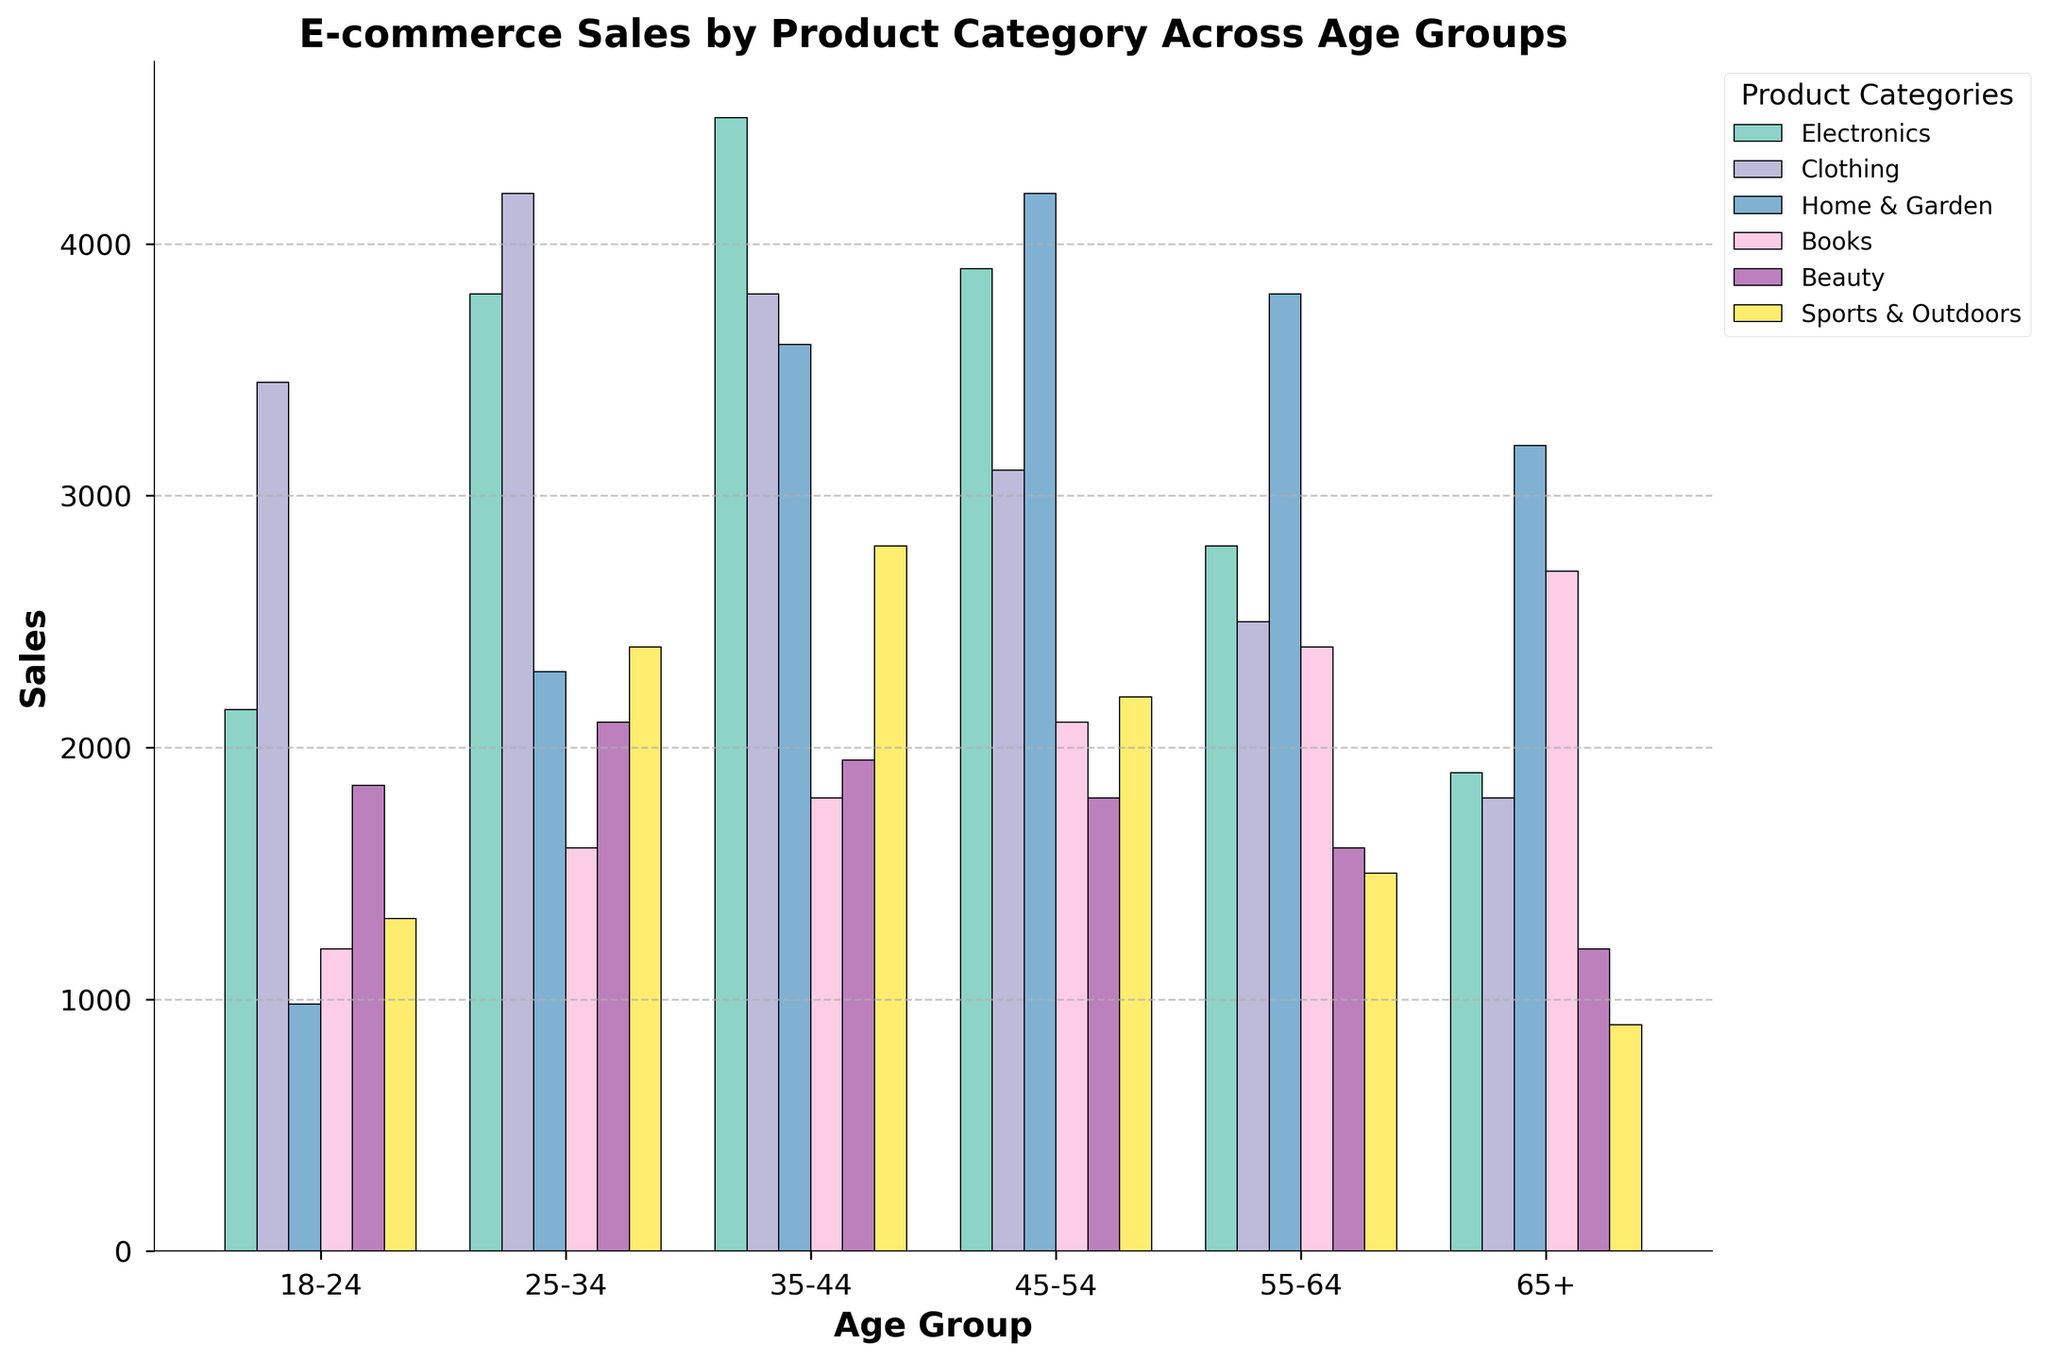What's the most popular product category for the age group 35-44? The bar representing each product category for the 35-44 age group shows that Electronics has the highest bar, indicating it has the highest number of sales.
Answer: Electronics How do sales for Home & Garden in the 45-54 age group compare to the 55-64 age group? By comparing the heights of the Home & Garden bars for the two age groups, we observe that the 55-64 age group has a slightly higher bar indicating more sales compared to the 45-54 age group.
Answer: 55-64 age group has higher sales Which age group has the highest total sales across all product categories? To determine this, sum up the heights of all the bars for each age group. The age group with the highest combined bar heights across categories is the one with the most sales. The 35-44 age group has the highest total sales across all categories.
Answer: 35-44 What is the difference in sales for Books between the youngest and oldest age groups? To find the difference, subtract the sales of Books in the 65+ age group from the sales in the 18-24 age group. The 65+ age group has a sales bar of 2700, and the 18-24 age group has a sales bar of 1200.
Answer: 1200-2700 = -1500 Which product category has the least variability in sales across all age groups? Observing the bars for each product category, Beauty appears to have the least variation in height across the age groups, indicating more uniform sales.
Answer: Beauty If you add the sales for Sports & Outdoors and Home & Garden in the 25-34 age group, what is the total? Add the sales for Sports & Outdoors (2400) and Home & Garden (2300) in the 25-34 age group.
Answer: 2400 + 2300 = 4700 Are sales for Clothing consistently high across all age groups? By observing the height of the bars for Clothing across all age groups, we see that they are relatively high compared to other categories, especially for 18-24 and 25-34 age groups.
Answer: Yes What fraction of the total sales for Electronics in the 25-34 age group is the Clothing sales in the same age group? First, note the sales for Electronics (3800) and Clothing (4200) for the 25-34 age group, then compute the fraction as 4200/3800.
Answer: 4200/3800 = 1.11 How do sales in the Books category for the 45-54 age group compare with Electronics sales in the 18-24 age group? By looking at the bars, the Books sales in the 45-54 age group (2100) are less than the Electronics sales in the 18-24 age group (2150).
Answer: Electronics in 18-24 is higher Compare the sales for Beauty products in the 18-24 age group with those in the 35-44 age group. The bars show that Beauty sales for the 18-24 age group (1850) are slightly lower than those in the 35-44 age group (1950).
Answer: 35-44 age group is higher 